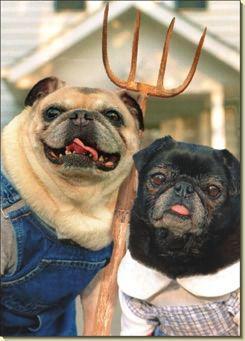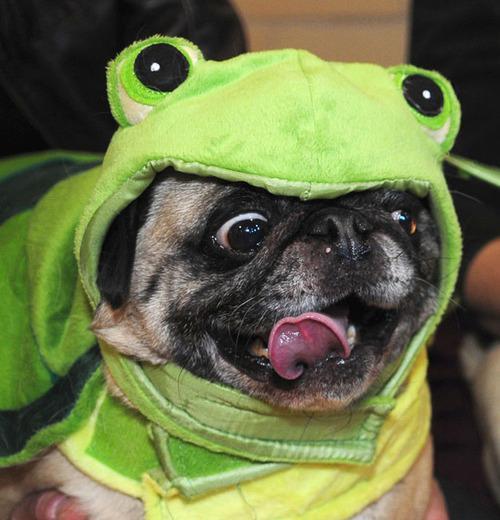The first image is the image on the left, the second image is the image on the right. Examine the images to the left and right. Is the description "There is at least three dogs." accurate? Answer yes or no. Yes. The first image is the image on the left, the second image is the image on the right. For the images displayed, is the sentence "Each image contains one pug wearing an outfit, including the letfthand dog wearing a grayish and yellow outift, and the righthand dog in formal human-like attire." factually correct? Answer yes or no. No. 